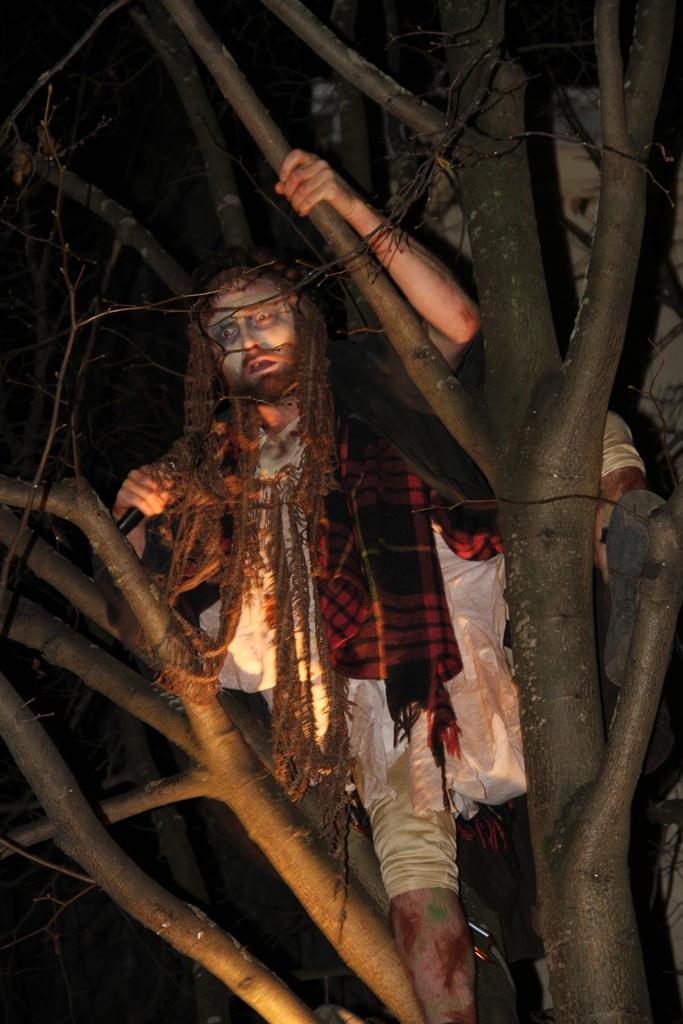Can you describe this image briefly? In this image I can see a person wearing different color costume and standing on the tree. Background is black in color. 